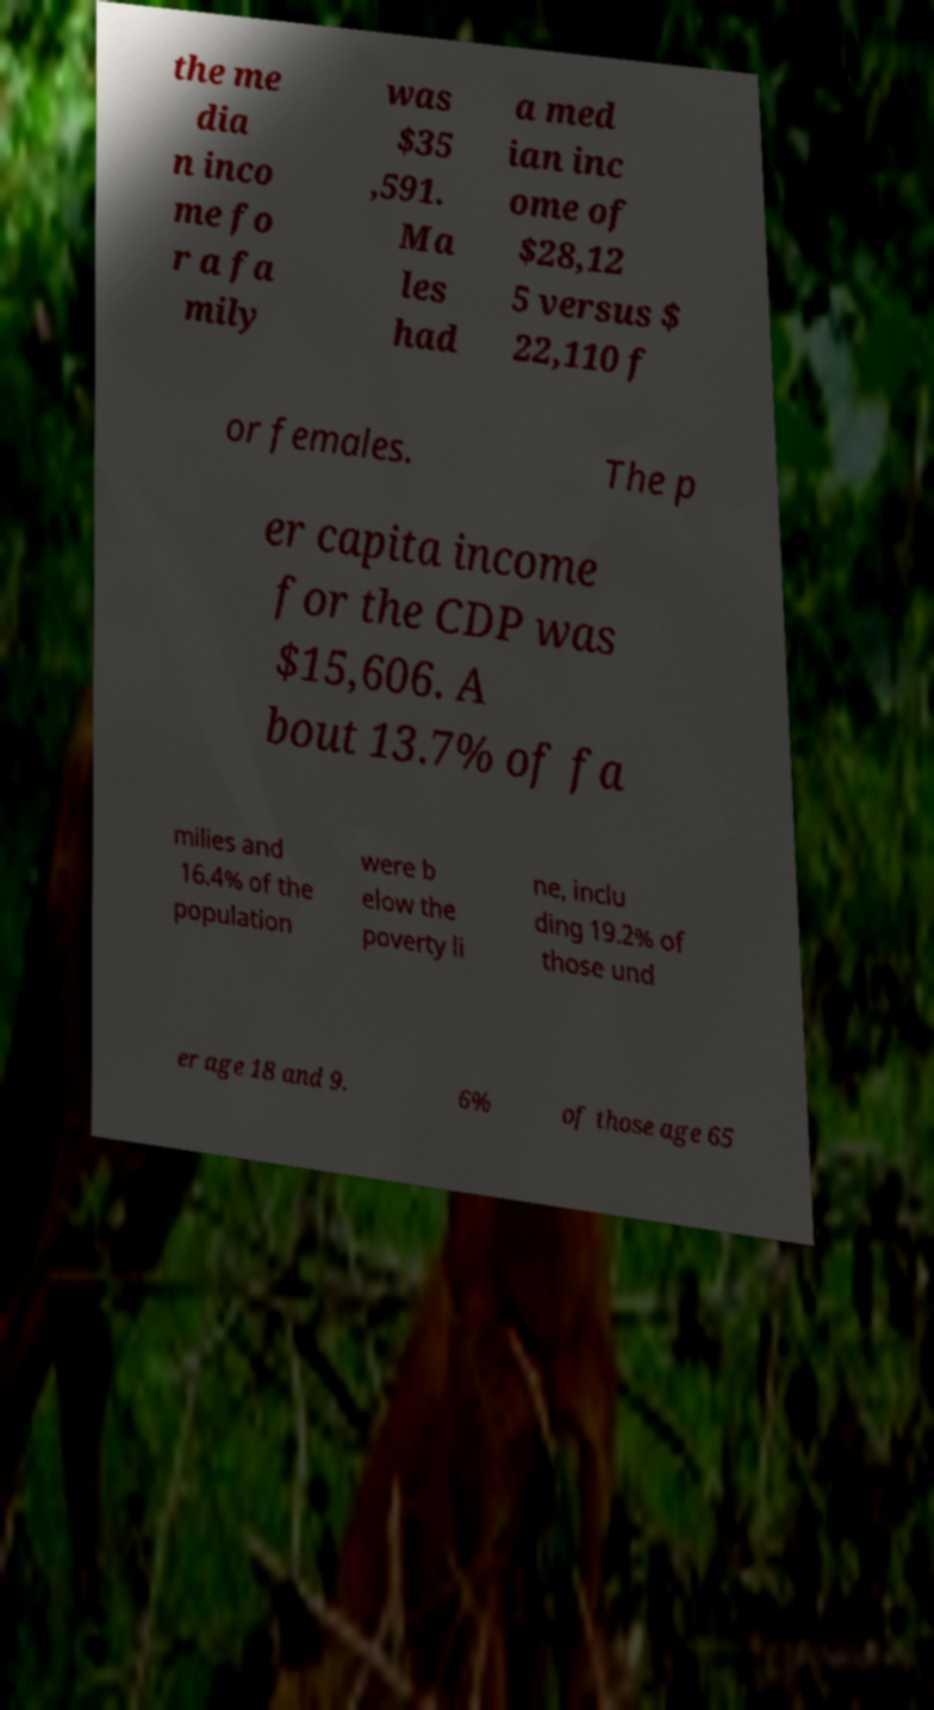I need the written content from this picture converted into text. Can you do that? the me dia n inco me fo r a fa mily was $35 ,591. Ma les had a med ian inc ome of $28,12 5 versus $ 22,110 f or females. The p er capita income for the CDP was $15,606. A bout 13.7% of fa milies and 16.4% of the population were b elow the poverty li ne, inclu ding 19.2% of those und er age 18 and 9. 6% of those age 65 